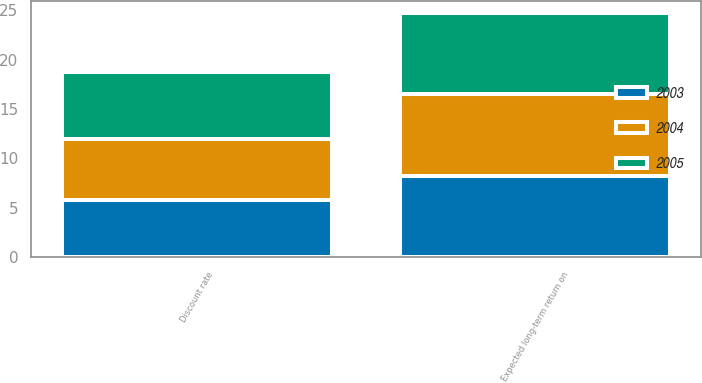Convert chart to OTSL. <chart><loc_0><loc_0><loc_500><loc_500><stacked_bar_chart><ecel><fcel>Discount rate<fcel>Expected long-term return on<nl><fcel>2003<fcel>5.8<fcel>8.25<nl><fcel>2004<fcel>6.2<fcel>8.25<nl><fcel>2005<fcel>6.75<fcel>8.25<nl></chart> 